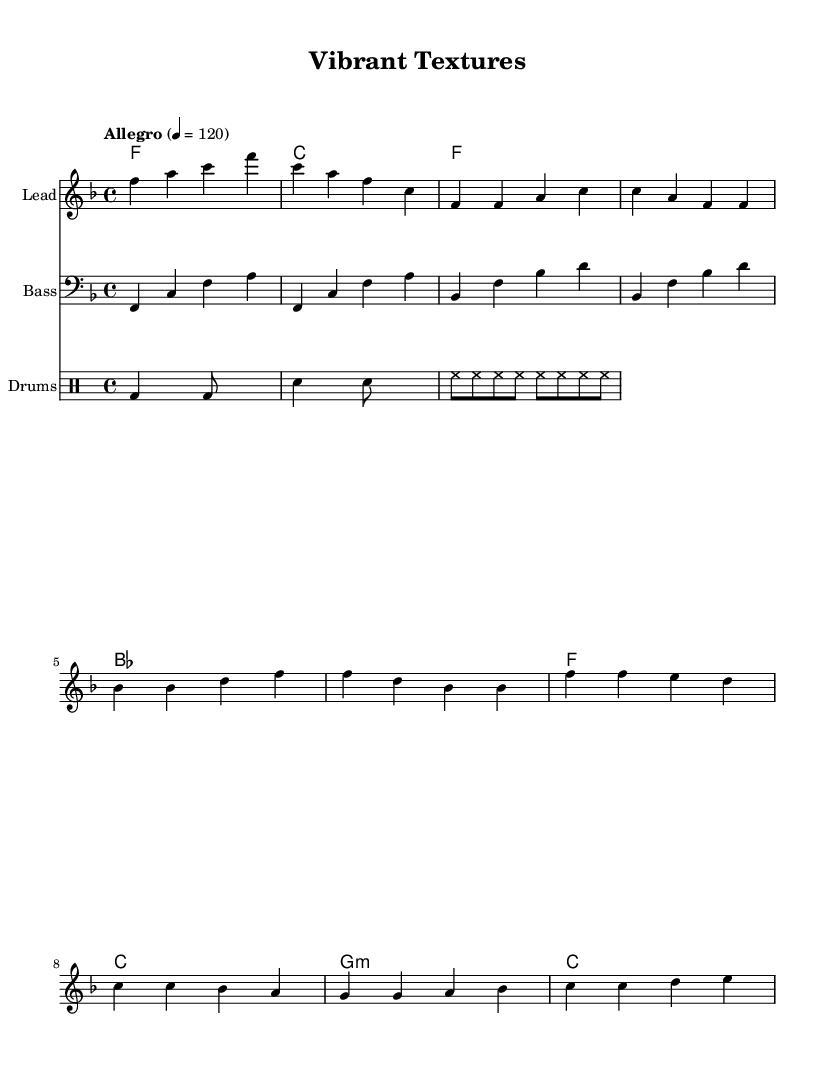What is the key signature of this music? The key signature can be found at the beginning of the music sheet and indicates one flat (B flat), which means it is in F major.
Answer: F major What is the time signature of the piece? The time signature is located after the key signature and indicates the number of beats in a measure; here it shows 4/4, meaning four beats per measure.
Answer: 4/4 What is the tempo marking for this piece? The tempo is indicated at the top of the sheet music with the term "Allegro," followed by a tempo indication of 120 beats per minute, meaning it should be played fast and lively.
Answer: Allegro How many measures are in the verse section? By counting the measures in the verse section, which specifically includes two sections of four measures each, we find there are eight measures total in the verse.
Answer: 8 What rhythm pattern is primarily used for the bass line? The bass line consists predominantly of quarter notes in a repetitive and rhythmic pattern, creating a driving feel characteristic of R&B.
Answer: Quarter notes What is the chord progression during the chorus? The chord changes in the chorus are derived from the harmonies part; it progresses through four chords: F major, C major, G minor, and C major appropriately matched with the melody.
Answer: F, C, G minor, C What is a notable characteristic of R&B music reflected in this score? The score exhibits a strong emphasis on groove and rhythm, shown through the rhythmic patterns in the drums and bass lines, which are highly typical of upbeat R&B tracks.
Answer: Groove and rhythm 